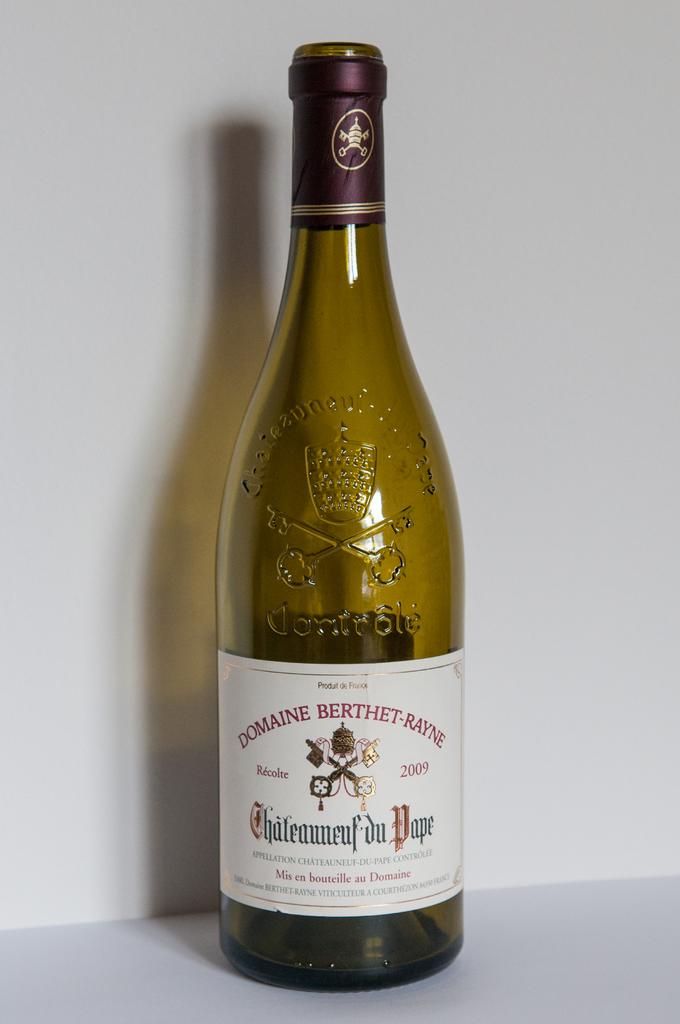Is domaine berthet rayne a french wine?
Provide a succinct answer. Yes. 